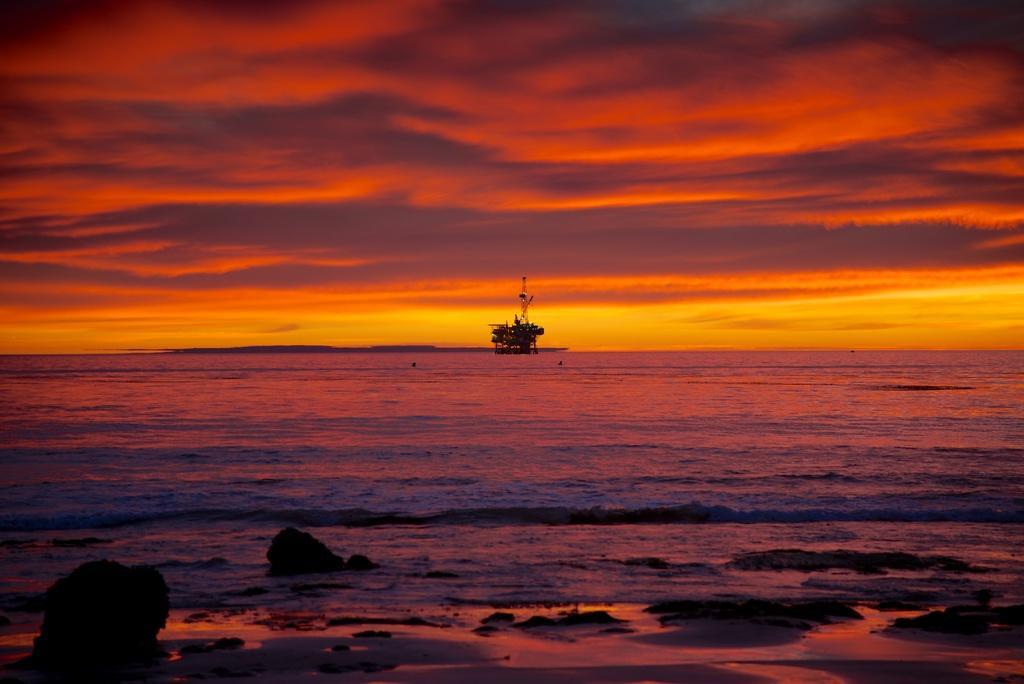In one or two sentences, can you explain what this image depicts? In the center of the image a boat is there. In the background of the image wall is there. At the top of the image sky is there. At the bottom of the image some rocks are there. 